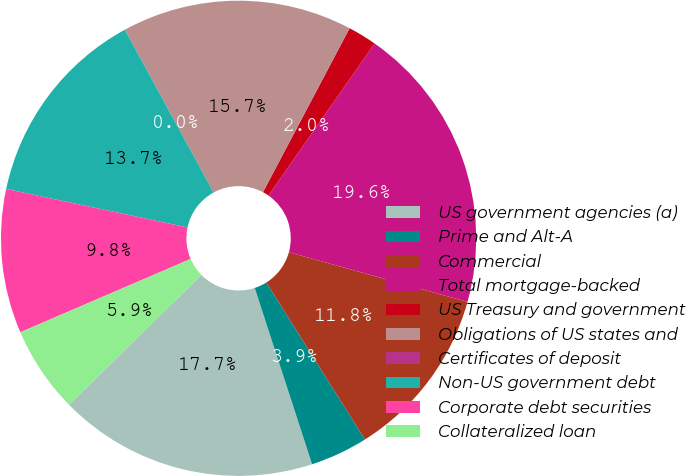Convert chart to OTSL. <chart><loc_0><loc_0><loc_500><loc_500><pie_chart><fcel>US government agencies (a)<fcel>Prime and Alt-A<fcel>Commercial<fcel>Total mortgage-backed<fcel>US Treasury and government<fcel>Obligations of US states and<fcel>Certificates of deposit<fcel>Non-US government debt<fcel>Corporate debt securities<fcel>Collateralized loan<nl><fcel>17.65%<fcel>3.92%<fcel>11.76%<fcel>19.61%<fcel>1.96%<fcel>15.68%<fcel>0.0%<fcel>13.72%<fcel>9.8%<fcel>5.88%<nl></chart> 